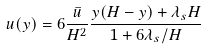Convert formula to latex. <formula><loc_0><loc_0><loc_500><loc_500>u ( y ) = 6 \frac { \bar { u } } { H ^ { 2 } } \frac { y ( H - y ) + \lambda _ { s } H } { 1 + 6 \lambda _ { s } / H }</formula> 